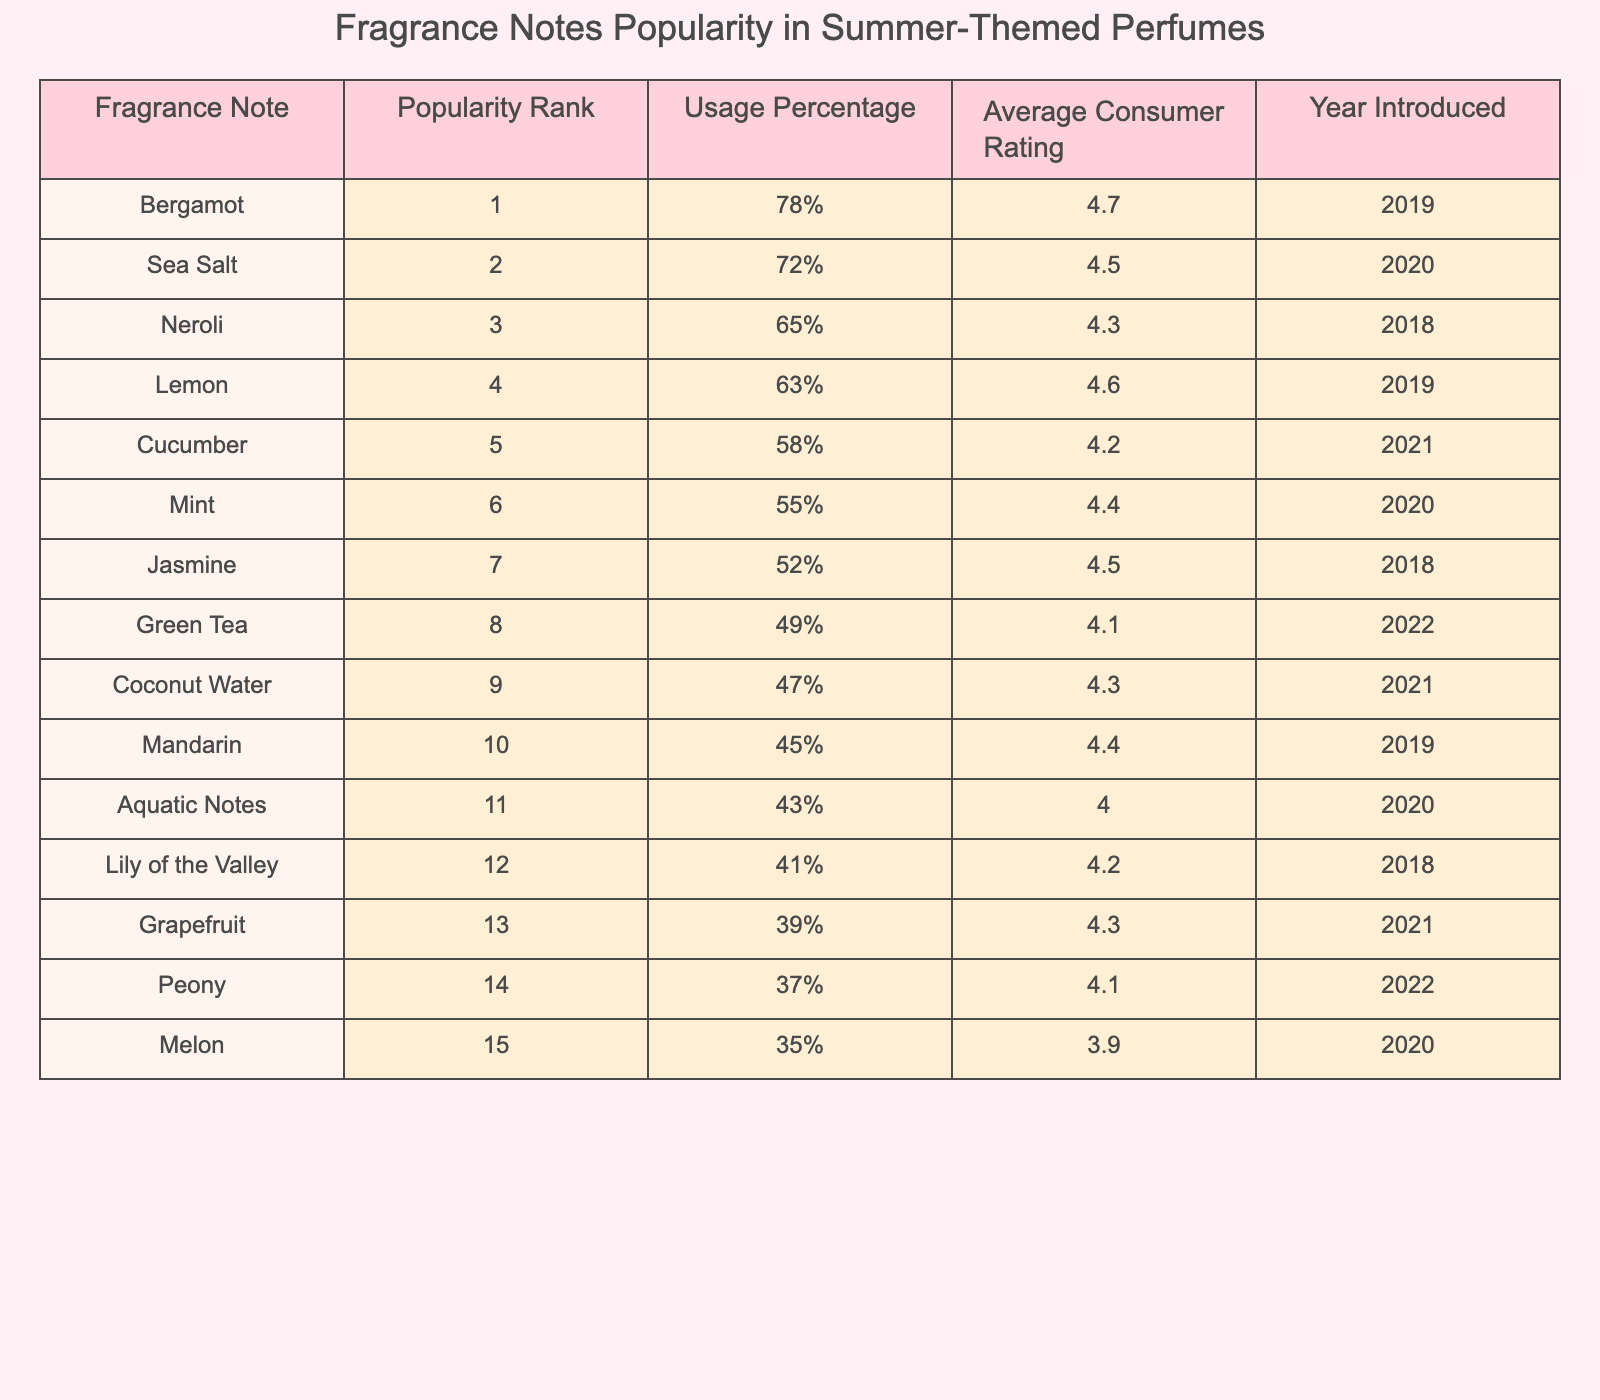What is the most popular fragrance note in summer-themed perfumes? The most popular fragrance note is the one with the highest popularity rank, which is Bergamot with a rank of 1.
Answer: Bergamot Which fragrance note has the lowest consumer rating? To find the lowest consumer rating, we look for the smallest value in the Average Consumer Rating column. The lowest rating is Melon with an average rating of 3.9.
Answer: Melon How many fragrance notes have a usage percentage of 50% or higher? We count the entries in the Usage Percentage column that are 50% or greater. The notes with usage percentages of 50% or higher are Bergamot, Sea Salt, Neroli, Lemon, Cucumber, Mint, Jasmine, and Aquatic Notes, totaling 8 notes.
Answer: 8 What fragrance notes were introduced in the year 2021? We look for the rows where the Year Introduced is 2021. The fragrance notes introduced in 2021 are Cucumber, Coconut Water, and Grapefruit.
Answer: Cucumber, Coconut Water, Grapefruit What is the average consumer rating of the top three fragrance notes? We first identify the top three fragrance notes, which are Bergamot, Sea Salt, and Neroli, with ratings of 4.7, 4.5, and 4.3 respectively. The average rating is calculated as (4.7 + 4.5 + 4.3) / 3 = 4.5.
Answer: 4.5 Does Jasmine have a higher usage percentage than Mint? To answer, we compare the usage percentages: Jasmine has 52% and Mint has 55%. Since 52% is less than 55%, the answer is no.
Answer: No What percentage difference in usage exists between the most popular and the least popular fragrance notes? The most popular note is Bergamot with a usage percentage of 78%, and the least popular note is Melon with a usage percentage of 35%. The percentage difference is calculated as 78% - 35% = 43%.
Answer: 43% Which fragrance note is ranked 10th and what is its average consumer rating? By referring to the table, the fragrance note ranked 10th is Mandarin, with an average consumer rating of 4.4.
Answer: Mandarin, 4.4 Are there any fragrance notes with a popularity rank higher than 10 that have a usage percentage above 30%? We check the ranks above 10 and find that all the ranks (from 11 to 15) have usage percentages above 30%: Aquatic Notes (43%), Lily of the Valley (41%), Grapefruit (39%), Peony (37%), and Melon (35%). Since these notes exist, the answer is yes.
Answer: Yes What is the relationship between Average Consumer Rating and Popularity Rank for the fragrance notes? We observe the trend: generally, a higher popularity rank corresponds to a higher average consumer rating, suggesting a positive correlation.
Answer: Positive correlation 